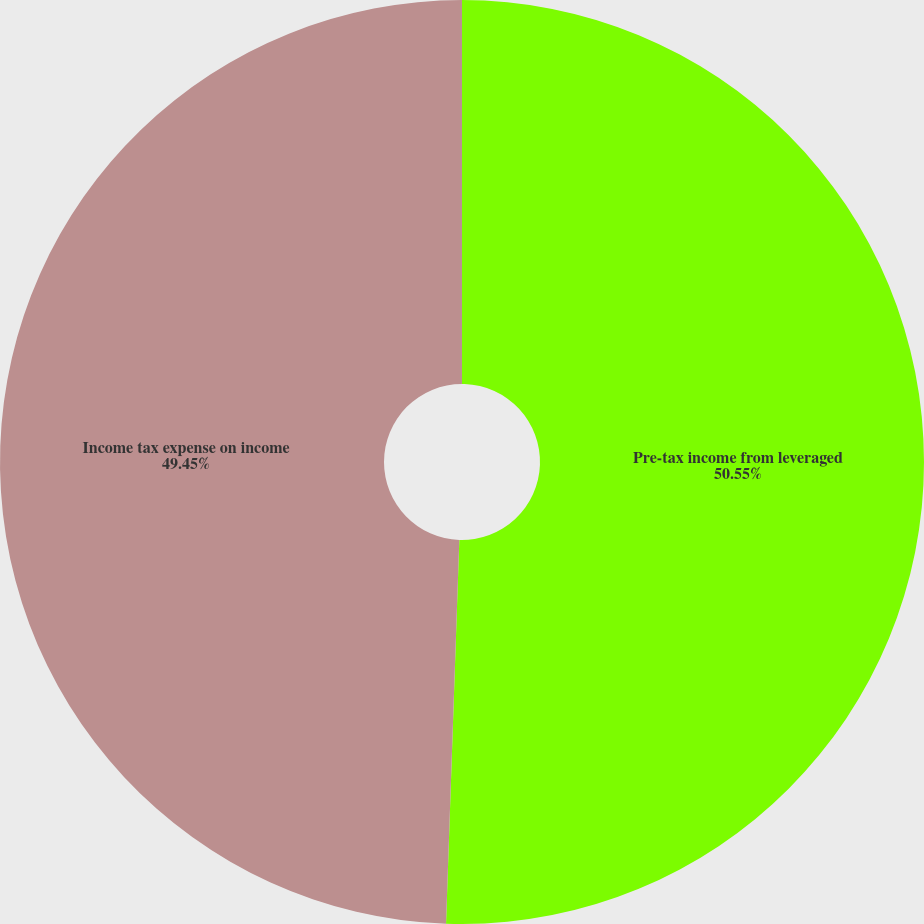Convert chart to OTSL. <chart><loc_0><loc_0><loc_500><loc_500><pie_chart><fcel>Pre-tax income from leveraged<fcel>Income tax expense on income<nl><fcel>50.55%<fcel>49.45%<nl></chart> 